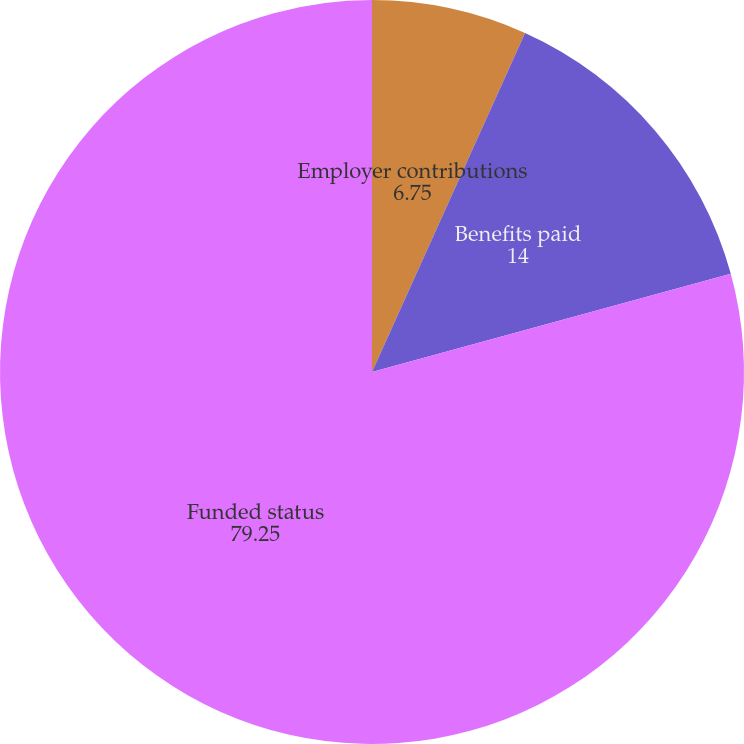Convert chart. <chart><loc_0><loc_0><loc_500><loc_500><pie_chart><fcel>Employer contributions<fcel>Benefits paid<fcel>Funded status<nl><fcel>6.75%<fcel>14.0%<fcel>79.25%<nl></chart> 